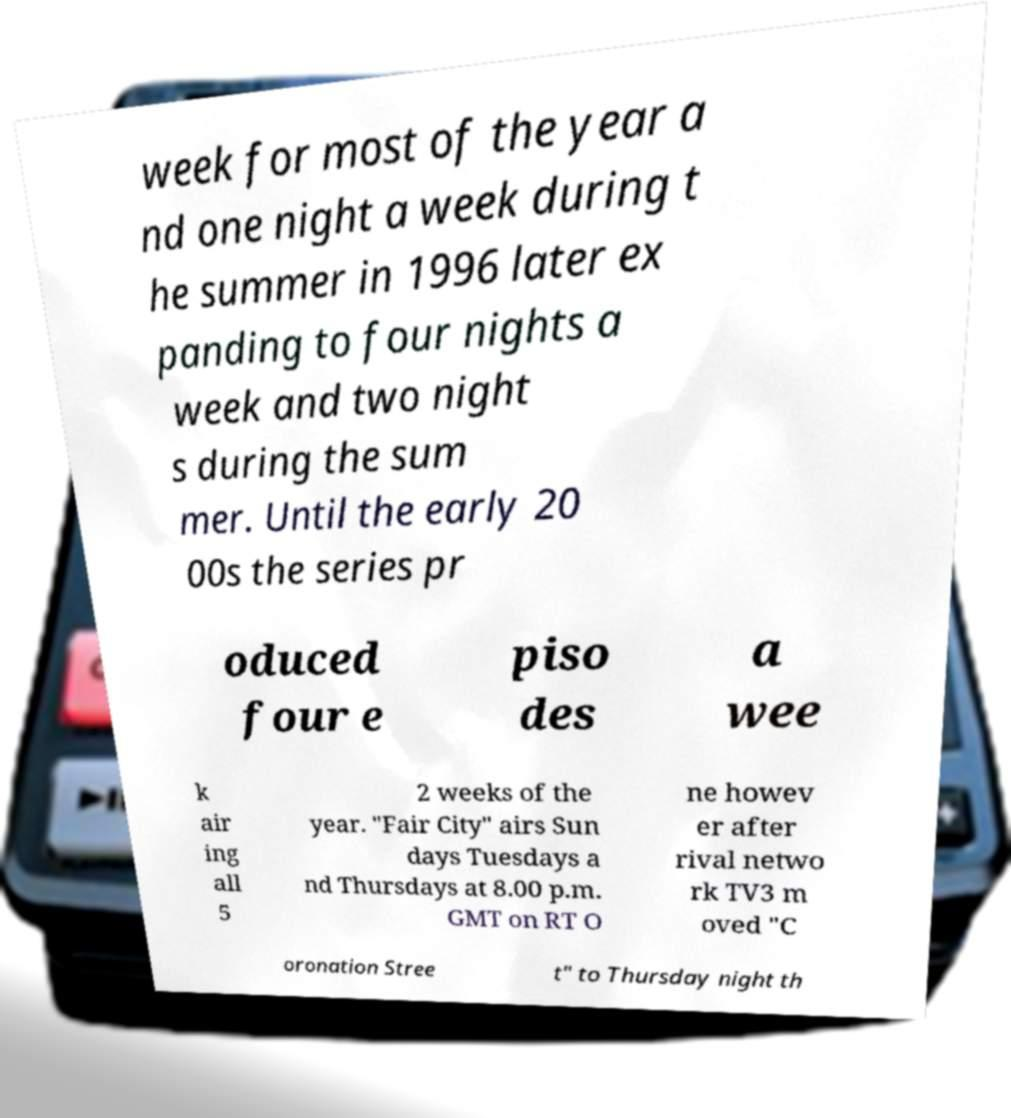For documentation purposes, I need the text within this image transcribed. Could you provide that? week for most of the year a nd one night a week during t he summer in 1996 later ex panding to four nights a week and two night s during the sum mer. Until the early 20 00s the series pr oduced four e piso des a wee k air ing all 5 2 weeks of the year. "Fair City" airs Sun days Tuesdays a nd Thursdays at 8.00 p.m. GMT on RT O ne howev er after rival netwo rk TV3 m oved "C oronation Stree t" to Thursday night th 